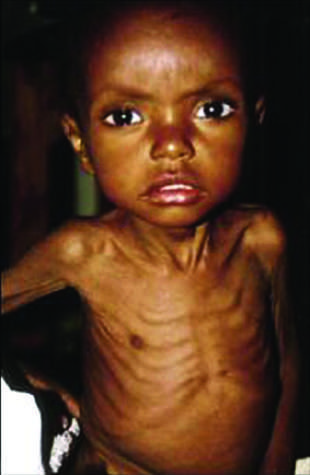does the head appear to be too large for the emaciated body?
Answer the question using a single word or phrase. Yes 